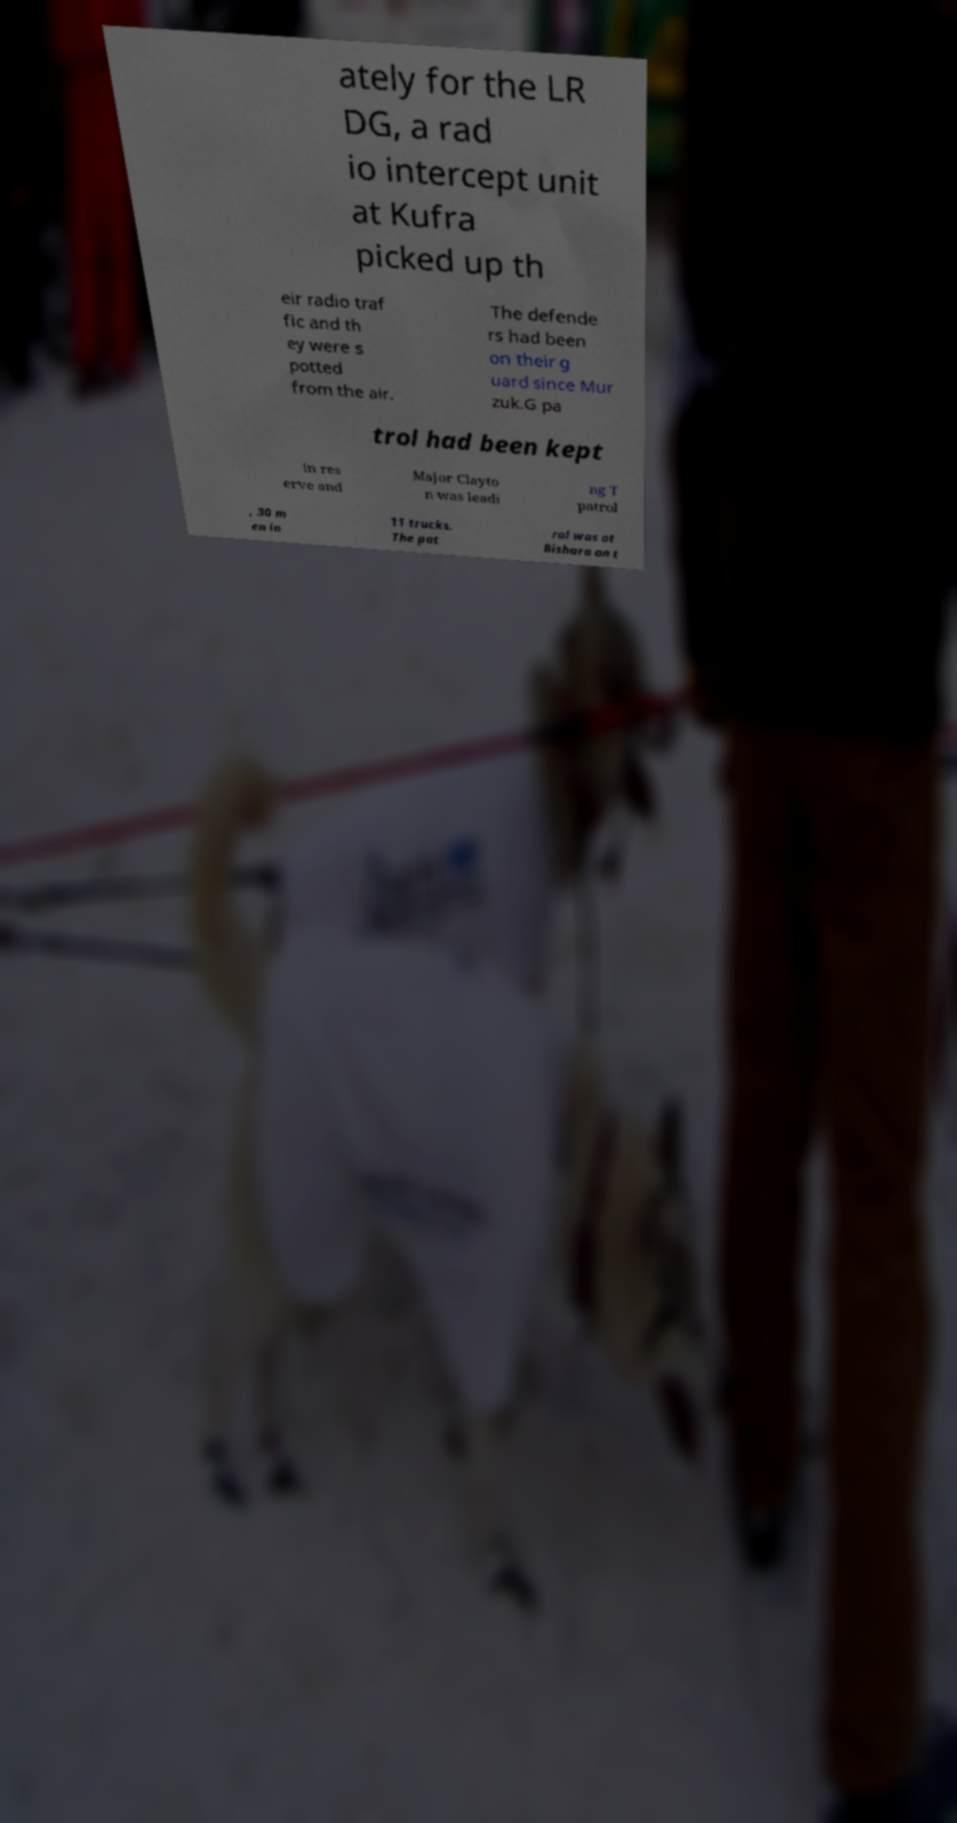Can you read and provide the text displayed in the image?This photo seems to have some interesting text. Can you extract and type it out for me? ately for the LR DG, a rad io intercept unit at Kufra picked up th eir radio traf fic and th ey were s potted from the air. The defende rs had been on their g uard since Mur zuk.G pa trol had been kept in res erve and Major Clayto n was leadi ng T patrol , 30 m en in 11 trucks. The pat rol was at Bishara on t 